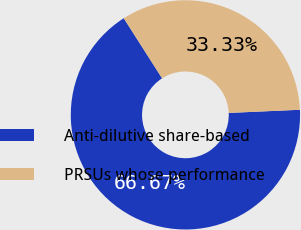<chart> <loc_0><loc_0><loc_500><loc_500><pie_chart><fcel>Anti-dilutive share-based<fcel>PRSUs whose performance<nl><fcel>66.67%<fcel>33.33%<nl></chart> 